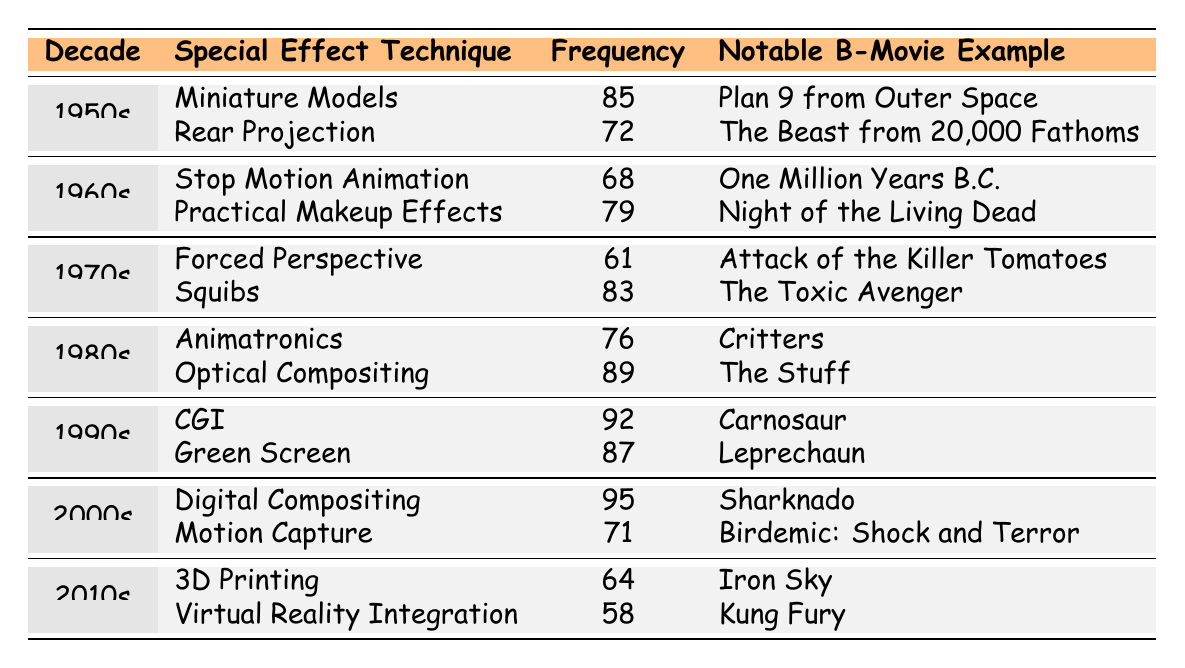What special effect technique had the highest frequency in the 2000s? In the 2000s, the table shows "Digital Compositing" with a frequency of 95, which is the highest among the techniques listed for that decade.
Answer: Digital Compositing Which special effect technique was most commonly used in the 1980s? The table indicates "Optical Compositing" with a frequency of 89 is the most used special effect technique in the 1980s.
Answer: Optical Compositing What is the frequency of "CGI" in the 1990s? The table shows that the frequency of CGI in the 1990s is 92.
Answer: 92 How many total uses of special effect techniques are listed for the 1970s? To find the total for the 1970s, we sum the frequencies of "Forced Perspective" (61) and "Squibs" (83), resulting in 61 + 83 = 144.
Answer: 144 Which decade had the least use of "Virtual Reality Integration"? The only instance of "Virtual Reality Integration" is in the 2010s, with a frequency of 58, which is lower compared to all other techniques across decades.
Answer: 2010s What is the average frequency of special effects used in the 1960s? In the 1960s, there are two techniques: "Stop Motion Animation" (68) and "Practical Makeup Effects" (79). The average is (68 + 79) / 2 = 73.5.
Answer: 73.5 Was "Motion Capture" used more than "3D Printing" in the 2000s? "Motion Capture" has a frequency of 71, which is lower than "Digital Compositing" (95) but not related directly to "3D Printing" (64). It can be stated that "Motion Capture" is higher than "3D Printing."
Answer: Yes Which technique had a higher frequency: "Rear Projection" or "Green Screen"? The frequency of "Rear Projection" is 72, while "Green Screen" has a frequency of 87. Thus, "Green Screen" is used more frequently than "Rear Projection."
Answer: Green Screen In which decade did "Squibs" have the highest frequency compared to its use in earlier decades? The frequency of "Squibs" in the 1970s is 83. By looking at earlier decades, "Miniature Models" (85) in the 1950s is higher, but in the 1970s it is the highest compared to its own decade use as no earlier technique exceeds it in later decades.
Answer: 1970s If you combine the frequencies of the two 2010s techniques, what is the total? The frequencies for "3D Printing" (64) and "Virtual Reality Integration" (58) add up to 64 + 58 = 122.
Answer: 122 